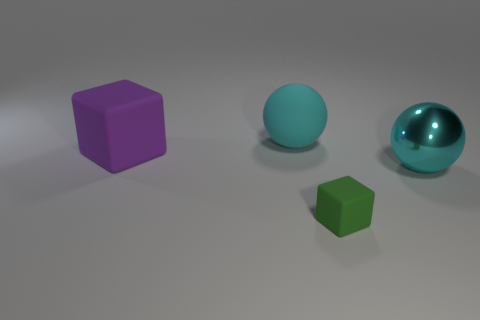Does the metal sphere have the same color as the large rubber ball? While the metal sphere and the large rubber ball share a bluish hue, the metal sphere has a reflective surface that gives it a shiny appearance, making its color seem to have varying shades depending on the light. On the other hand, the rubber ball has a matte finish with a more consistent coloration. 